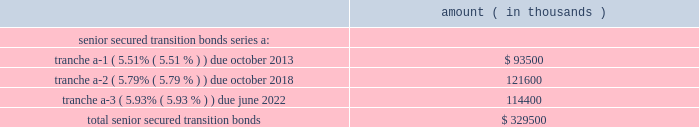Entergy corporation and subsidiaries notes to financial statements in november 2000 , entergy's non-utility nuclear business purchased the fitzpatrick and indian point 3 power plants in a seller-financed transaction .
Entergy issued notes to nypa with seven annual installments of approximately $ 108 million commencing one year from the date of the closing , and eight annual installments of $ 20 million commencing eight years from the date of the closing .
These notes do not have a stated interest rate , but have an implicit interest rate of 4.8% ( 4.8 % ) .
In accordance with the purchase agreement with nypa , the purchase of indian point 2 in 2001 resulted in entergy's non-utility nuclear business becoming liable to nypa for an additional $ 10 million per year for 10 years , beginning in september 2003 .
This liability was recorded upon the purchase of indian point 2 in september 2001 , and is included in the note payable to nypa balance above .
In july 2003 , a payment of $ 102 million was made prior to maturity on the note payable to nypa .
Under a provision in a letter of credit supporting these notes , if certain of the utility operating companies or system energy were to default on other indebtedness , entergy could be required to post collateral to support the letter of credit .
Covenants in the entergy corporation notes require it to maintain a consolidated debt ratio of 65% ( 65 % ) or less of its total capitalization .
If entergy's debt ratio exceeds this limit , or if entergy corporation or certain of the utility operating companies default on other indebtedness or are in bankruptcy or insolvency proceedings , an acceleration of the notes' maturity dates may occur .
Entergy gulf states louisiana , entergy louisiana , entergy mississippi , entergy texas , and system energy have received ferc long-term financing orders authorizing long-term securities issuances .
Entergy arkansas has received an apsc long-term financing order authorizing long-term securities issuances .
The long-term securities issuances of entergy new orleans are limited to amounts authorized by the city council , and the current authorization extends through august 2010 .
Capital funds agreement pursuant to an agreement with certain creditors , entergy corporation has agreed to supply system energy with sufficient capital to : maintain system energy's equity capital at a minimum of 35% ( 35 % ) of its total capitalization ( excluding short- term debt ) ; permit the continued commercial operation of grand gulf ; pay in full all system energy indebtedness for borrowed money when due ; and enable system energy to make payments on specific system energy debt , under supplements to the agreement assigning system energy's rights in the agreement as security for the specific debt .
Entergy texas securitization bonds - hurricane rita in april 2007 , the puct issued a financing order authorizing the issuance of securitization bonds to recover $ 353 million of entergy texas' hurricane rita reconstruction costs and up to $ 6 million of transaction costs , offset by $ 32 million of related deferred income tax benefits .
In june 2007 , entergy gulf states reconstruction funding i , llc , a company wholly-owned and consolidated by entergy texas , issued $ 329.5 million of senior secured transition bonds ( securitization bonds ) , as follows : amount ( in thousands ) .

What was the sum of the notes issued by entergy to nypa? 
Computations: ((7 + 108) + (20 + 8))
Answer: 143.0. 